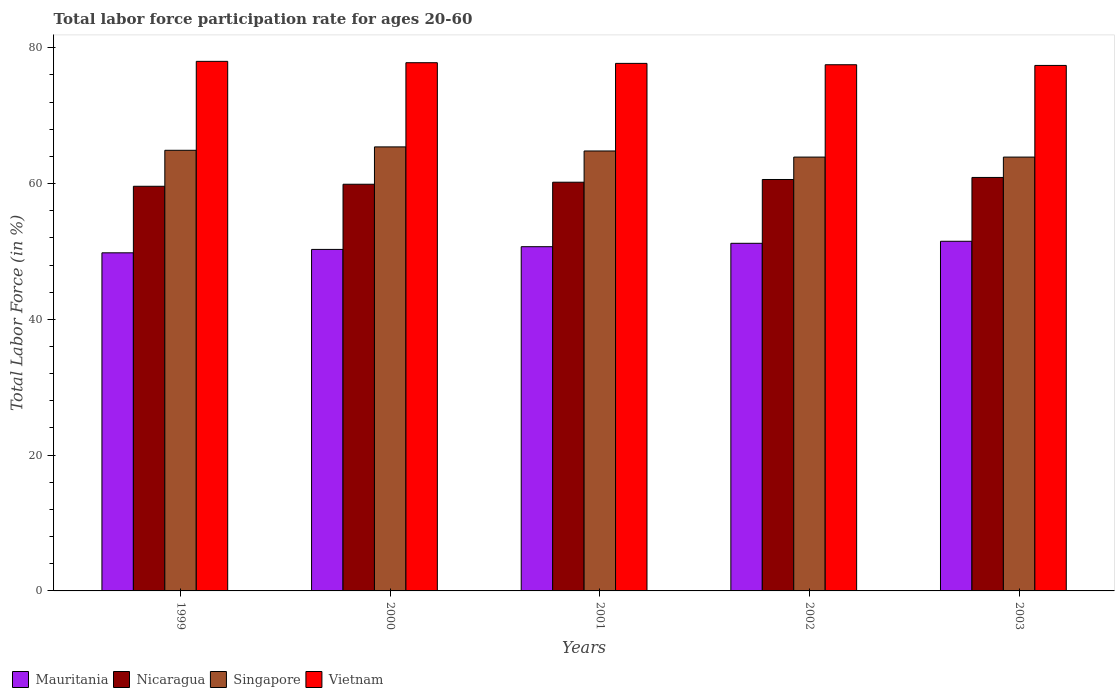How many groups of bars are there?
Make the answer very short. 5. Are the number of bars per tick equal to the number of legend labels?
Your answer should be very brief. Yes. How many bars are there on the 1st tick from the left?
Make the answer very short. 4. How many bars are there on the 3rd tick from the right?
Offer a very short reply. 4. In how many cases, is the number of bars for a given year not equal to the number of legend labels?
Provide a short and direct response. 0. What is the labor force participation rate in Mauritania in 2000?
Keep it short and to the point. 50.3. Across all years, what is the minimum labor force participation rate in Singapore?
Keep it short and to the point. 63.9. In which year was the labor force participation rate in Nicaragua minimum?
Your answer should be compact. 1999. What is the total labor force participation rate in Mauritania in the graph?
Your response must be concise. 253.5. What is the difference between the labor force participation rate in Nicaragua in 2002 and that in 2003?
Give a very brief answer. -0.3. What is the difference between the labor force participation rate in Singapore in 2000 and the labor force participation rate in Nicaragua in 2003?
Ensure brevity in your answer.  4.5. What is the average labor force participation rate in Vietnam per year?
Offer a very short reply. 77.68. In the year 1999, what is the difference between the labor force participation rate in Vietnam and labor force participation rate in Nicaragua?
Provide a succinct answer. 18.4. In how many years, is the labor force participation rate in Vietnam greater than 32 %?
Keep it short and to the point. 5. What is the ratio of the labor force participation rate in Mauritania in 2002 to that in 2003?
Your response must be concise. 0.99. Is the labor force participation rate in Vietnam in 2000 less than that in 2002?
Give a very brief answer. No. Is the difference between the labor force participation rate in Vietnam in 1999 and 2001 greater than the difference between the labor force participation rate in Nicaragua in 1999 and 2001?
Give a very brief answer. Yes. What is the difference between the highest and the second highest labor force participation rate in Singapore?
Provide a short and direct response. 0.5. What is the difference between the highest and the lowest labor force participation rate in Vietnam?
Ensure brevity in your answer.  0.6. Is it the case that in every year, the sum of the labor force participation rate in Singapore and labor force participation rate in Mauritania is greater than the sum of labor force participation rate in Nicaragua and labor force participation rate in Vietnam?
Your answer should be very brief. No. What does the 1st bar from the left in 2000 represents?
Make the answer very short. Mauritania. What does the 4th bar from the right in 1999 represents?
Your answer should be very brief. Mauritania. How many bars are there?
Provide a short and direct response. 20. What is the difference between two consecutive major ticks on the Y-axis?
Your answer should be compact. 20. How are the legend labels stacked?
Your response must be concise. Horizontal. What is the title of the graph?
Give a very brief answer. Total labor force participation rate for ages 20-60. Does "Cuba" appear as one of the legend labels in the graph?
Offer a terse response. No. What is the label or title of the X-axis?
Provide a succinct answer. Years. What is the Total Labor Force (in %) of Mauritania in 1999?
Give a very brief answer. 49.8. What is the Total Labor Force (in %) in Nicaragua in 1999?
Provide a succinct answer. 59.6. What is the Total Labor Force (in %) in Singapore in 1999?
Your answer should be very brief. 64.9. What is the Total Labor Force (in %) of Mauritania in 2000?
Provide a succinct answer. 50.3. What is the Total Labor Force (in %) of Nicaragua in 2000?
Keep it short and to the point. 59.9. What is the Total Labor Force (in %) of Singapore in 2000?
Your answer should be compact. 65.4. What is the Total Labor Force (in %) of Vietnam in 2000?
Provide a succinct answer. 77.8. What is the Total Labor Force (in %) of Mauritania in 2001?
Offer a terse response. 50.7. What is the Total Labor Force (in %) in Nicaragua in 2001?
Keep it short and to the point. 60.2. What is the Total Labor Force (in %) in Singapore in 2001?
Offer a very short reply. 64.8. What is the Total Labor Force (in %) of Vietnam in 2001?
Make the answer very short. 77.7. What is the Total Labor Force (in %) in Mauritania in 2002?
Your answer should be very brief. 51.2. What is the Total Labor Force (in %) in Nicaragua in 2002?
Offer a very short reply. 60.6. What is the Total Labor Force (in %) of Singapore in 2002?
Ensure brevity in your answer.  63.9. What is the Total Labor Force (in %) of Vietnam in 2002?
Provide a short and direct response. 77.5. What is the Total Labor Force (in %) of Mauritania in 2003?
Keep it short and to the point. 51.5. What is the Total Labor Force (in %) of Nicaragua in 2003?
Your response must be concise. 60.9. What is the Total Labor Force (in %) in Singapore in 2003?
Make the answer very short. 63.9. What is the Total Labor Force (in %) of Vietnam in 2003?
Your answer should be very brief. 77.4. Across all years, what is the maximum Total Labor Force (in %) of Mauritania?
Provide a succinct answer. 51.5. Across all years, what is the maximum Total Labor Force (in %) of Nicaragua?
Make the answer very short. 60.9. Across all years, what is the maximum Total Labor Force (in %) of Singapore?
Make the answer very short. 65.4. Across all years, what is the minimum Total Labor Force (in %) in Mauritania?
Give a very brief answer. 49.8. Across all years, what is the minimum Total Labor Force (in %) in Nicaragua?
Provide a short and direct response. 59.6. Across all years, what is the minimum Total Labor Force (in %) of Singapore?
Your answer should be very brief. 63.9. Across all years, what is the minimum Total Labor Force (in %) in Vietnam?
Keep it short and to the point. 77.4. What is the total Total Labor Force (in %) of Mauritania in the graph?
Your response must be concise. 253.5. What is the total Total Labor Force (in %) of Nicaragua in the graph?
Provide a short and direct response. 301.2. What is the total Total Labor Force (in %) of Singapore in the graph?
Provide a short and direct response. 322.9. What is the total Total Labor Force (in %) of Vietnam in the graph?
Offer a very short reply. 388.4. What is the difference between the Total Labor Force (in %) of Nicaragua in 1999 and that in 2000?
Ensure brevity in your answer.  -0.3. What is the difference between the Total Labor Force (in %) of Mauritania in 1999 and that in 2001?
Keep it short and to the point. -0.9. What is the difference between the Total Labor Force (in %) in Nicaragua in 1999 and that in 2001?
Offer a very short reply. -0.6. What is the difference between the Total Labor Force (in %) of Singapore in 1999 and that in 2001?
Give a very brief answer. 0.1. What is the difference between the Total Labor Force (in %) in Mauritania in 1999 and that in 2003?
Provide a short and direct response. -1.7. What is the difference between the Total Labor Force (in %) in Nicaragua in 1999 and that in 2003?
Your response must be concise. -1.3. What is the difference between the Total Labor Force (in %) of Singapore in 1999 and that in 2003?
Offer a terse response. 1. What is the difference between the Total Labor Force (in %) in Vietnam in 1999 and that in 2003?
Give a very brief answer. 0.6. What is the difference between the Total Labor Force (in %) of Nicaragua in 2000 and that in 2001?
Your response must be concise. -0.3. What is the difference between the Total Labor Force (in %) of Mauritania in 2000 and that in 2002?
Give a very brief answer. -0.9. What is the difference between the Total Labor Force (in %) of Singapore in 2000 and that in 2003?
Provide a short and direct response. 1.5. What is the difference between the Total Labor Force (in %) in Vietnam in 2000 and that in 2003?
Your answer should be compact. 0.4. What is the difference between the Total Labor Force (in %) in Mauritania in 2001 and that in 2002?
Provide a succinct answer. -0.5. What is the difference between the Total Labor Force (in %) of Nicaragua in 2001 and that in 2002?
Provide a succinct answer. -0.4. What is the difference between the Total Labor Force (in %) of Singapore in 2001 and that in 2002?
Provide a short and direct response. 0.9. What is the difference between the Total Labor Force (in %) in Nicaragua in 2001 and that in 2003?
Ensure brevity in your answer.  -0.7. What is the difference between the Total Labor Force (in %) of Singapore in 2001 and that in 2003?
Provide a short and direct response. 0.9. What is the difference between the Total Labor Force (in %) of Vietnam in 2001 and that in 2003?
Offer a very short reply. 0.3. What is the difference between the Total Labor Force (in %) in Nicaragua in 2002 and that in 2003?
Ensure brevity in your answer.  -0.3. What is the difference between the Total Labor Force (in %) of Mauritania in 1999 and the Total Labor Force (in %) of Singapore in 2000?
Make the answer very short. -15.6. What is the difference between the Total Labor Force (in %) in Mauritania in 1999 and the Total Labor Force (in %) in Vietnam in 2000?
Make the answer very short. -28. What is the difference between the Total Labor Force (in %) of Nicaragua in 1999 and the Total Labor Force (in %) of Singapore in 2000?
Your answer should be compact. -5.8. What is the difference between the Total Labor Force (in %) in Nicaragua in 1999 and the Total Labor Force (in %) in Vietnam in 2000?
Provide a short and direct response. -18.2. What is the difference between the Total Labor Force (in %) of Mauritania in 1999 and the Total Labor Force (in %) of Vietnam in 2001?
Your response must be concise. -27.9. What is the difference between the Total Labor Force (in %) in Nicaragua in 1999 and the Total Labor Force (in %) in Singapore in 2001?
Your answer should be very brief. -5.2. What is the difference between the Total Labor Force (in %) of Nicaragua in 1999 and the Total Labor Force (in %) of Vietnam in 2001?
Your answer should be compact. -18.1. What is the difference between the Total Labor Force (in %) in Mauritania in 1999 and the Total Labor Force (in %) in Nicaragua in 2002?
Keep it short and to the point. -10.8. What is the difference between the Total Labor Force (in %) of Mauritania in 1999 and the Total Labor Force (in %) of Singapore in 2002?
Provide a short and direct response. -14.1. What is the difference between the Total Labor Force (in %) in Mauritania in 1999 and the Total Labor Force (in %) in Vietnam in 2002?
Offer a very short reply. -27.7. What is the difference between the Total Labor Force (in %) of Nicaragua in 1999 and the Total Labor Force (in %) of Singapore in 2002?
Keep it short and to the point. -4.3. What is the difference between the Total Labor Force (in %) of Nicaragua in 1999 and the Total Labor Force (in %) of Vietnam in 2002?
Make the answer very short. -17.9. What is the difference between the Total Labor Force (in %) of Singapore in 1999 and the Total Labor Force (in %) of Vietnam in 2002?
Your response must be concise. -12.6. What is the difference between the Total Labor Force (in %) of Mauritania in 1999 and the Total Labor Force (in %) of Nicaragua in 2003?
Make the answer very short. -11.1. What is the difference between the Total Labor Force (in %) of Mauritania in 1999 and the Total Labor Force (in %) of Singapore in 2003?
Make the answer very short. -14.1. What is the difference between the Total Labor Force (in %) of Mauritania in 1999 and the Total Labor Force (in %) of Vietnam in 2003?
Ensure brevity in your answer.  -27.6. What is the difference between the Total Labor Force (in %) of Nicaragua in 1999 and the Total Labor Force (in %) of Singapore in 2003?
Your answer should be very brief. -4.3. What is the difference between the Total Labor Force (in %) of Nicaragua in 1999 and the Total Labor Force (in %) of Vietnam in 2003?
Ensure brevity in your answer.  -17.8. What is the difference between the Total Labor Force (in %) in Singapore in 1999 and the Total Labor Force (in %) in Vietnam in 2003?
Keep it short and to the point. -12.5. What is the difference between the Total Labor Force (in %) in Mauritania in 2000 and the Total Labor Force (in %) in Nicaragua in 2001?
Keep it short and to the point. -9.9. What is the difference between the Total Labor Force (in %) in Mauritania in 2000 and the Total Labor Force (in %) in Singapore in 2001?
Your response must be concise. -14.5. What is the difference between the Total Labor Force (in %) in Mauritania in 2000 and the Total Labor Force (in %) in Vietnam in 2001?
Your response must be concise. -27.4. What is the difference between the Total Labor Force (in %) in Nicaragua in 2000 and the Total Labor Force (in %) in Singapore in 2001?
Your answer should be very brief. -4.9. What is the difference between the Total Labor Force (in %) in Nicaragua in 2000 and the Total Labor Force (in %) in Vietnam in 2001?
Your response must be concise. -17.8. What is the difference between the Total Labor Force (in %) of Mauritania in 2000 and the Total Labor Force (in %) of Singapore in 2002?
Provide a succinct answer. -13.6. What is the difference between the Total Labor Force (in %) of Mauritania in 2000 and the Total Labor Force (in %) of Vietnam in 2002?
Your answer should be compact. -27.2. What is the difference between the Total Labor Force (in %) of Nicaragua in 2000 and the Total Labor Force (in %) of Singapore in 2002?
Provide a succinct answer. -4. What is the difference between the Total Labor Force (in %) in Nicaragua in 2000 and the Total Labor Force (in %) in Vietnam in 2002?
Make the answer very short. -17.6. What is the difference between the Total Labor Force (in %) in Mauritania in 2000 and the Total Labor Force (in %) in Vietnam in 2003?
Your response must be concise. -27.1. What is the difference between the Total Labor Force (in %) of Nicaragua in 2000 and the Total Labor Force (in %) of Vietnam in 2003?
Provide a short and direct response. -17.5. What is the difference between the Total Labor Force (in %) of Singapore in 2000 and the Total Labor Force (in %) of Vietnam in 2003?
Your answer should be very brief. -12. What is the difference between the Total Labor Force (in %) of Mauritania in 2001 and the Total Labor Force (in %) of Vietnam in 2002?
Your answer should be compact. -26.8. What is the difference between the Total Labor Force (in %) in Nicaragua in 2001 and the Total Labor Force (in %) in Singapore in 2002?
Provide a succinct answer. -3.7. What is the difference between the Total Labor Force (in %) of Nicaragua in 2001 and the Total Labor Force (in %) of Vietnam in 2002?
Offer a terse response. -17.3. What is the difference between the Total Labor Force (in %) of Mauritania in 2001 and the Total Labor Force (in %) of Vietnam in 2003?
Provide a short and direct response. -26.7. What is the difference between the Total Labor Force (in %) in Nicaragua in 2001 and the Total Labor Force (in %) in Vietnam in 2003?
Offer a terse response. -17.2. What is the difference between the Total Labor Force (in %) in Singapore in 2001 and the Total Labor Force (in %) in Vietnam in 2003?
Your answer should be compact. -12.6. What is the difference between the Total Labor Force (in %) in Mauritania in 2002 and the Total Labor Force (in %) in Nicaragua in 2003?
Offer a terse response. -9.7. What is the difference between the Total Labor Force (in %) of Mauritania in 2002 and the Total Labor Force (in %) of Singapore in 2003?
Give a very brief answer. -12.7. What is the difference between the Total Labor Force (in %) in Mauritania in 2002 and the Total Labor Force (in %) in Vietnam in 2003?
Keep it short and to the point. -26.2. What is the difference between the Total Labor Force (in %) in Nicaragua in 2002 and the Total Labor Force (in %) in Singapore in 2003?
Provide a short and direct response. -3.3. What is the difference between the Total Labor Force (in %) of Nicaragua in 2002 and the Total Labor Force (in %) of Vietnam in 2003?
Offer a terse response. -16.8. What is the average Total Labor Force (in %) of Mauritania per year?
Your response must be concise. 50.7. What is the average Total Labor Force (in %) of Nicaragua per year?
Ensure brevity in your answer.  60.24. What is the average Total Labor Force (in %) in Singapore per year?
Make the answer very short. 64.58. What is the average Total Labor Force (in %) in Vietnam per year?
Keep it short and to the point. 77.68. In the year 1999, what is the difference between the Total Labor Force (in %) in Mauritania and Total Labor Force (in %) in Nicaragua?
Offer a terse response. -9.8. In the year 1999, what is the difference between the Total Labor Force (in %) in Mauritania and Total Labor Force (in %) in Singapore?
Offer a very short reply. -15.1. In the year 1999, what is the difference between the Total Labor Force (in %) of Mauritania and Total Labor Force (in %) of Vietnam?
Provide a succinct answer. -28.2. In the year 1999, what is the difference between the Total Labor Force (in %) of Nicaragua and Total Labor Force (in %) of Vietnam?
Provide a short and direct response. -18.4. In the year 2000, what is the difference between the Total Labor Force (in %) in Mauritania and Total Labor Force (in %) in Singapore?
Give a very brief answer. -15.1. In the year 2000, what is the difference between the Total Labor Force (in %) in Mauritania and Total Labor Force (in %) in Vietnam?
Provide a succinct answer. -27.5. In the year 2000, what is the difference between the Total Labor Force (in %) of Nicaragua and Total Labor Force (in %) of Singapore?
Keep it short and to the point. -5.5. In the year 2000, what is the difference between the Total Labor Force (in %) in Nicaragua and Total Labor Force (in %) in Vietnam?
Ensure brevity in your answer.  -17.9. In the year 2001, what is the difference between the Total Labor Force (in %) in Mauritania and Total Labor Force (in %) in Singapore?
Provide a short and direct response. -14.1. In the year 2001, what is the difference between the Total Labor Force (in %) in Nicaragua and Total Labor Force (in %) in Singapore?
Your response must be concise. -4.6. In the year 2001, what is the difference between the Total Labor Force (in %) of Nicaragua and Total Labor Force (in %) of Vietnam?
Your answer should be very brief. -17.5. In the year 2002, what is the difference between the Total Labor Force (in %) in Mauritania and Total Labor Force (in %) in Nicaragua?
Your answer should be compact. -9.4. In the year 2002, what is the difference between the Total Labor Force (in %) of Mauritania and Total Labor Force (in %) of Singapore?
Provide a succinct answer. -12.7. In the year 2002, what is the difference between the Total Labor Force (in %) in Mauritania and Total Labor Force (in %) in Vietnam?
Provide a short and direct response. -26.3. In the year 2002, what is the difference between the Total Labor Force (in %) in Nicaragua and Total Labor Force (in %) in Vietnam?
Your answer should be compact. -16.9. In the year 2003, what is the difference between the Total Labor Force (in %) of Mauritania and Total Labor Force (in %) of Vietnam?
Offer a very short reply. -25.9. In the year 2003, what is the difference between the Total Labor Force (in %) of Nicaragua and Total Labor Force (in %) of Vietnam?
Ensure brevity in your answer.  -16.5. What is the ratio of the Total Labor Force (in %) in Vietnam in 1999 to that in 2000?
Your response must be concise. 1. What is the ratio of the Total Labor Force (in %) of Mauritania in 1999 to that in 2001?
Offer a terse response. 0.98. What is the ratio of the Total Labor Force (in %) in Mauritania in 1999 to that in 2002?
Make the answer very short. 0.97. What is the ratio of the Total Labor Force (in %) of Nicaragua in 1999 to that in 2002?
Give a very brief answer. 0.98. What is the ratio of the Total Labor Force (in %) of Singapore in 1999 to that in 2002?
Provide a short and direct response. 1.02. What is the ratio of the Total Labor Force (in %) of Vietnam in 1999 to that in 2002?
Offer a very short reply. 1.01. What is the ratio of the Total Labor Force (in %) of Mauritania in 1999 to that in 2003?
Your answer should be compact. 0.97. What is the ratio of the Total Labor Force (in %) of Nicaragua in 1999 to that in 2003?
Your response must be concise. 0.98. What is the ratio of the Total Labor Force (in %) in Singapore in 1999 to that in 2003?
Provide a succinct answer. 1.02. What is the ratio of the Total Labor Force (in %) of Vietnam in 1999 to that in 2003?
Offer a very short reply. 1.01. What is the ratio of the Total Labor Force (in %) in Nicaragua in 2000 to that in 2001?
Provide a succinct answer. 0.99. What is the ratio of the Total Labor Force (in %) of Singapore in 2000 to that in 2001?
Offer a terse response. 1.01. What is the ratio of the Total Labor Force (in %) in Vietnam in 2000 to that in 2001?
Offer a terse response. 1. What is the ratio of the Total Labor Force (in %) of Mauritania in 2000 to that in 2002?
Keep it short and to the point. 0.98. What is the ratio of the Total Labor Force (in %) in Nicaragua in 2000 to that in 2002?
Your answer should be compact. 0.99. What is the ratio of the Total Labor Force (in %) of Singapore in 2000 to that in 2002?
Your answer should be very brief. 1.02. What is the ratio of the Total Labor Force (in %) of Mauritania in 2000 to that in 2003?
Keep it short and to the point. 0.98. What is the ratio of the Total Labor Force (in %) of Nicaragua in 2000 to that in 2003?
Your response must be concise. 0.98. What is the ratio of the Total Labor Force (in %) in Singapore in 2000 to that in 2003?
Offer a terse response. 1.02. What is the ratio of the Total Labor Force (in %) in Vietnam in 2000 to that in 2003?
Offer a very short reply. 1.01. What is the ratio of the Total Labor Force (in %) of Mauritania in 2001 to that in 2002?
Ensure brevity in your answer.  0.99. What is the ratio of the Total Labor Force (in %) of Singapore in 2001 to that in 2002?
Offer a terse response. 1.01. What is the ratio of the Total Labor Force (in %) of Vietnam in 2001 to that in 2002?
Your response must be concise. 1. What is the ratio of the Total Labor Force (in %) of Mauritania in 2001 to that in 2003?
Keep it short and to the point. 0.98. What is the ratio of the Total Labor Force (in %) in Nicaragua in 2001 to that in 2003?
Make the answer very short. 0.99. What is the ratio of the Total Labor Force (in %) in Singapore in 2001 to that in 2003?
Your answer should be very brief. 1.01. What is the ratio of the Total Labor Force (in %) of Vietnam in 2002 to that in 2003?
Your answer should be very brief. 1. What is the difference between the highest and the second highest Total Labor Force (in %) of Mauritania?
Make the answer very short. 0.3. What is the difference between the highest and the second highest Total Labor Force (in %) of Nicaragua?
Provide a short and direct response. 0.3. What is the difference between the highest and the second highest Total Labor Force (in %) of Vietnam?
Offer a terse response. 0.2. 